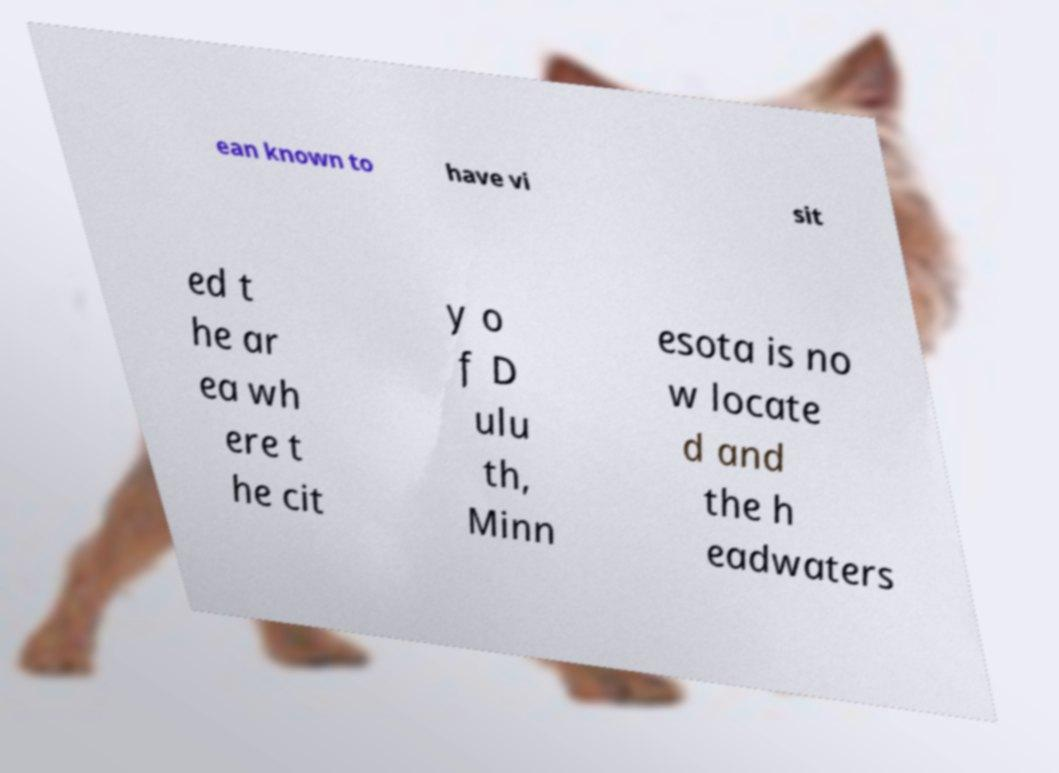Could you extract and type out the text from this image? ean known to have vi sit ed t he ar ea wh ere t he cit y o f D ulu th, Minn esota is no w locate d and the h eadwaters 